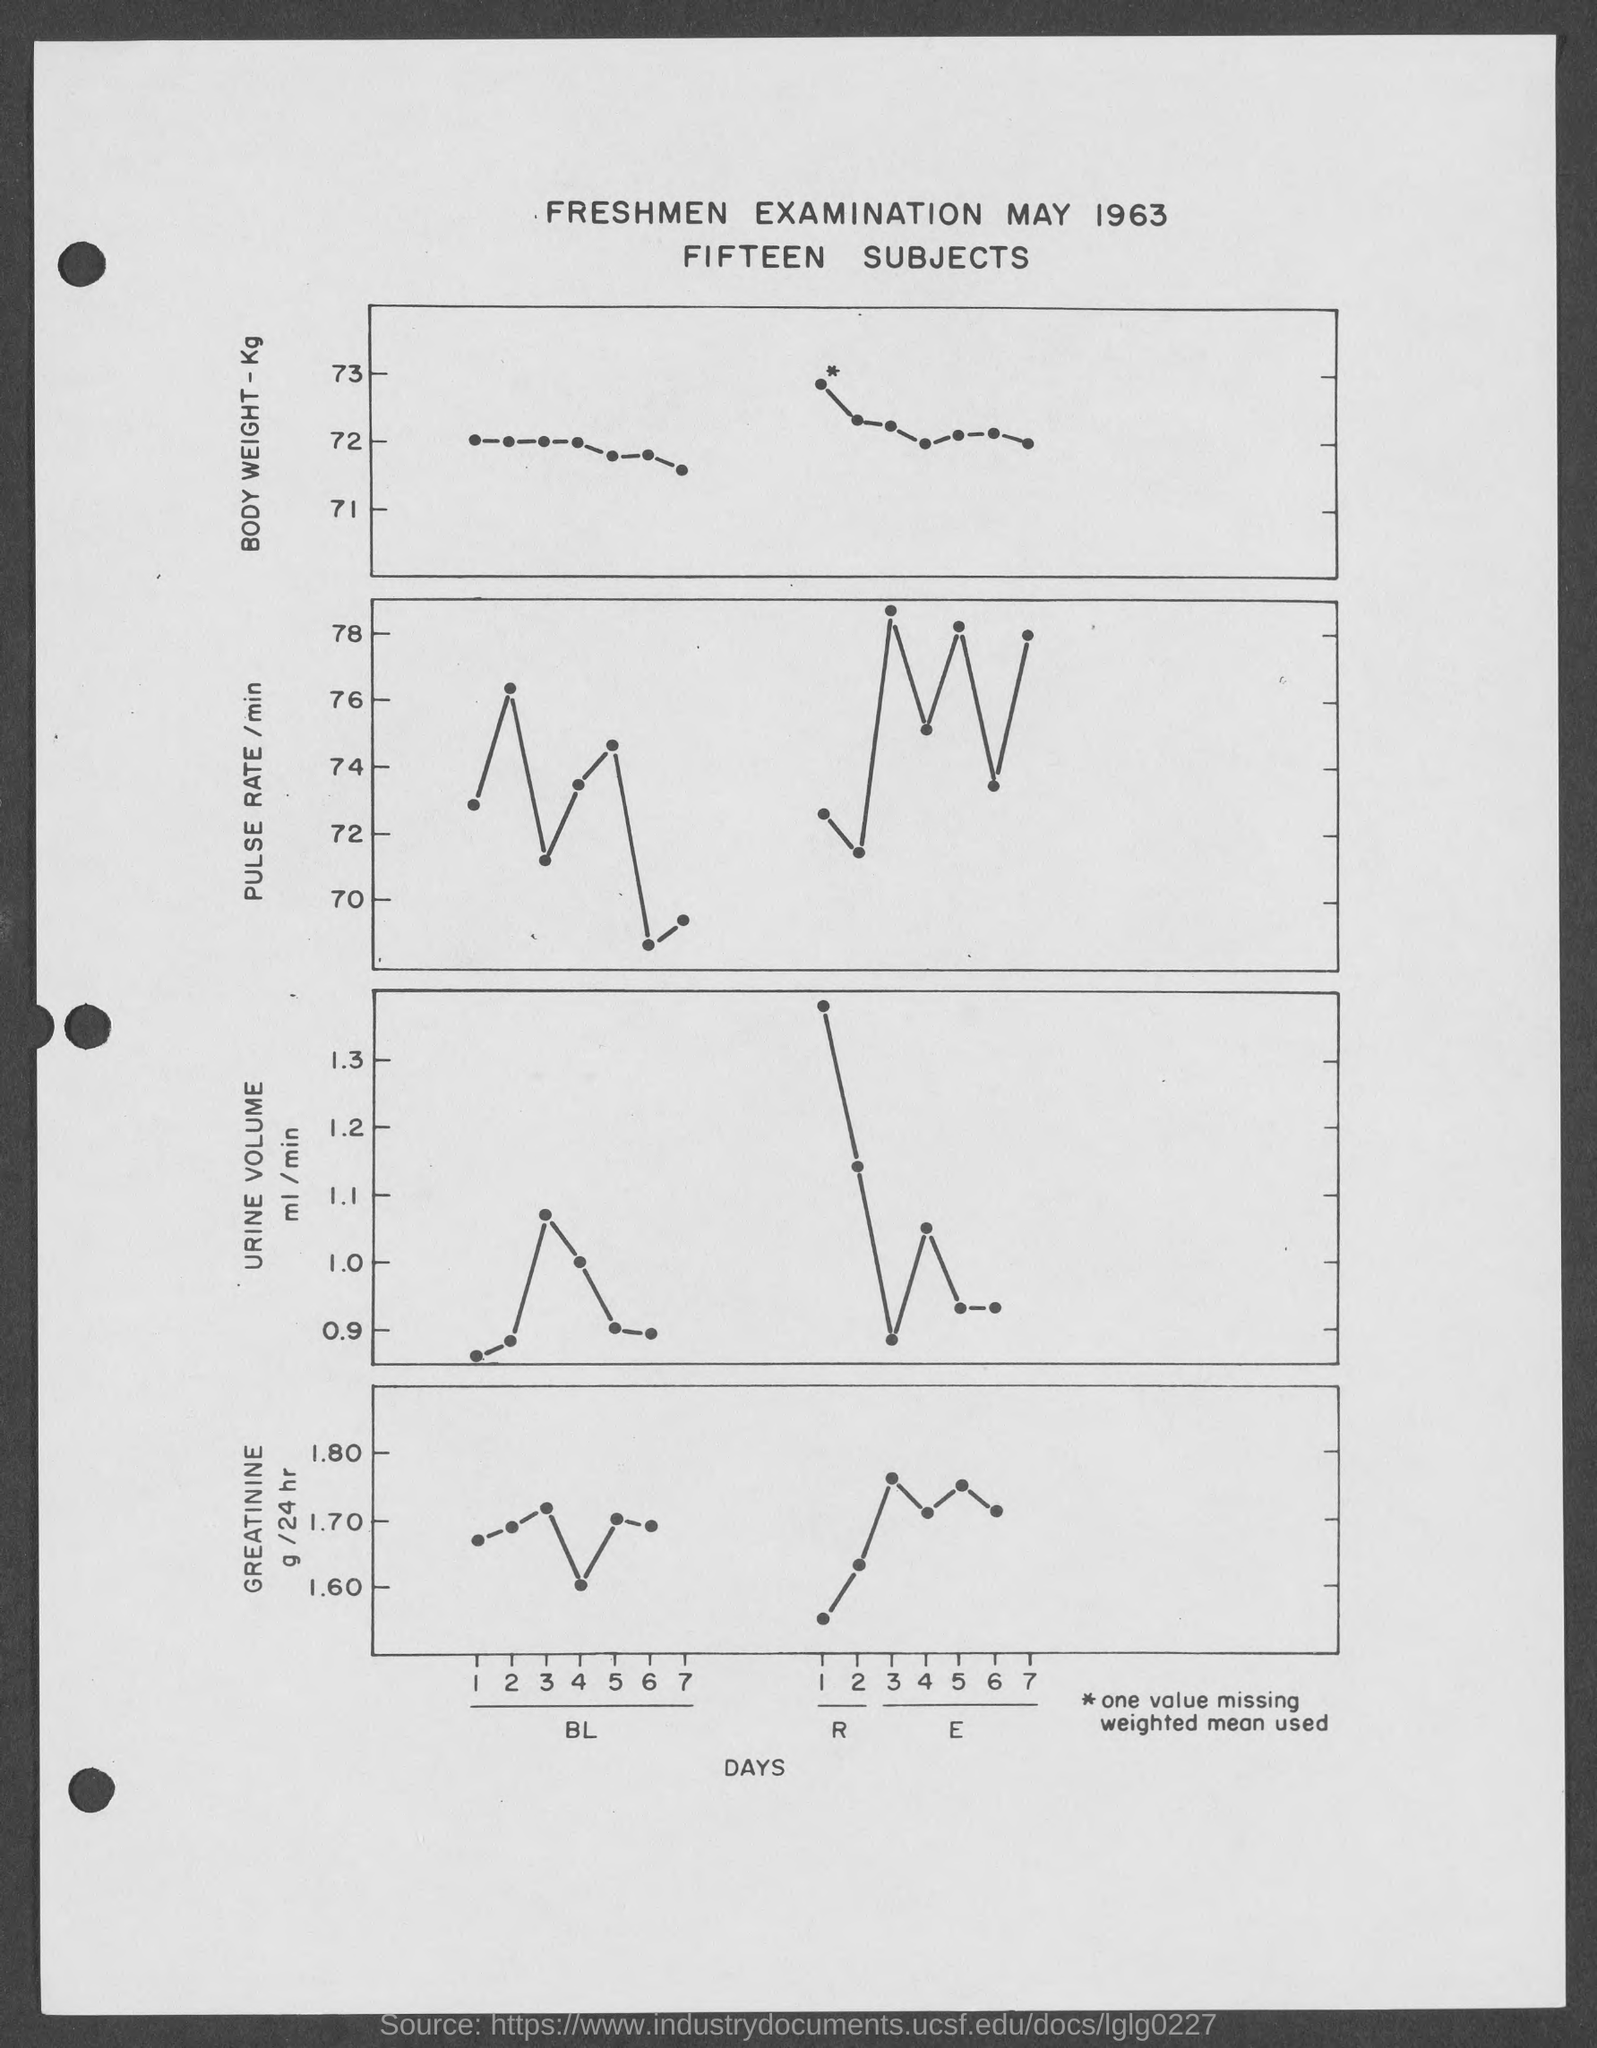What is the first title in the document?
Your answer should be compact. Freshmen Examination May 1963. What is the second title in the document?
Keep it short and to the point. Fifteen Subjects. What is on the x-axis of all graphs?
Give a very brief answer. Days. 